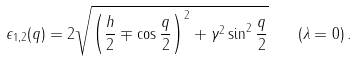Convert formula to latex. <formula><loc_0><loc_0><loc_500><loc_500>\epsilon _ { 1 , 2 } ( q ) = 2 \sqrt { \left ( \frac { h } { 2 } \mp \cos \frac { q } { 2 } \right ) ^ { 2 } + \gamma ^ { 2 } \sin ^ { 2 } \frac { q } { 2 } } \quad ( \lambda = 0 ) \, .</formula> 